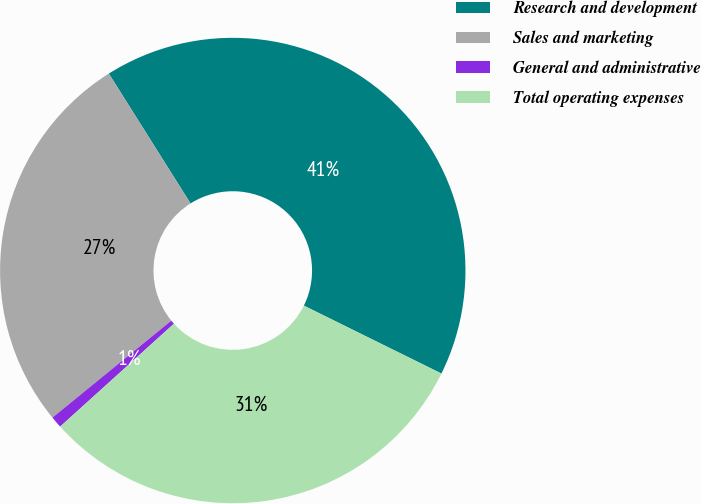<chart> <loc_0><loc_0><loc_500><loc_500><pie_chart><fcel>Research and development<fcel>Sales and marketing<fcel>General and administrative<fcel>Total operating expenses<nl><fcel>41.24%<fcel>26.95%<fcel>0.81%<fcel>31.0%<nl></chart> 